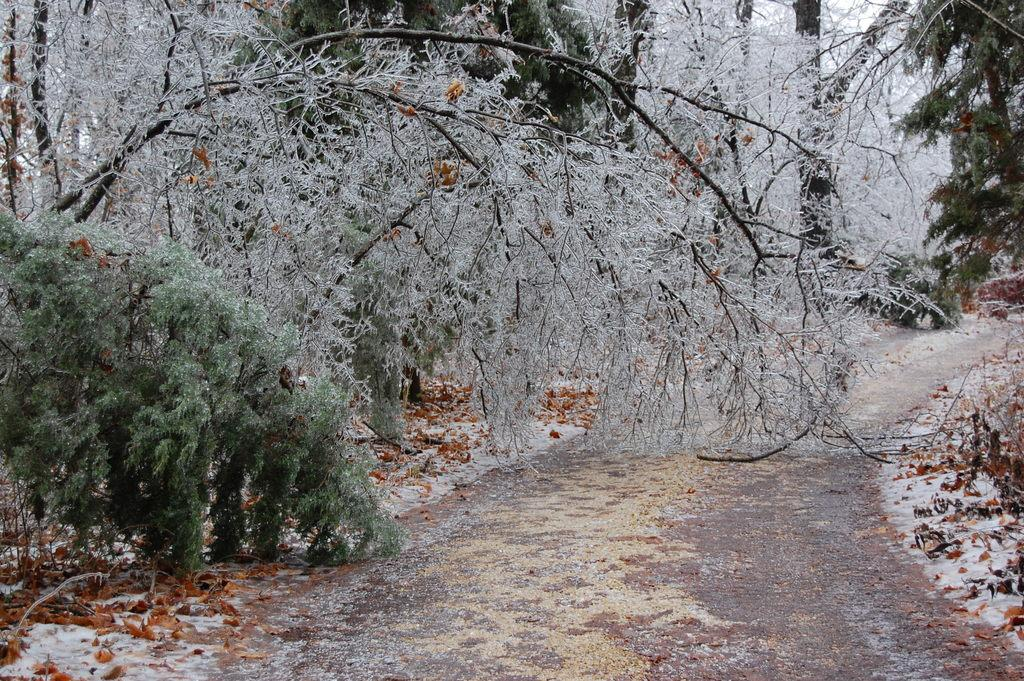What type of vegetation can be seen in the image? There are many trees and plants in the image. What is located at the bottom of the image? There is a road at the bottom of the image. What type of fruit is hanging from the trees in the image? There is no fruit visible on the trees in the image. What is the weather like in the image? The provided facts do not mention the weather, so we cannot determine the weather from the image. 